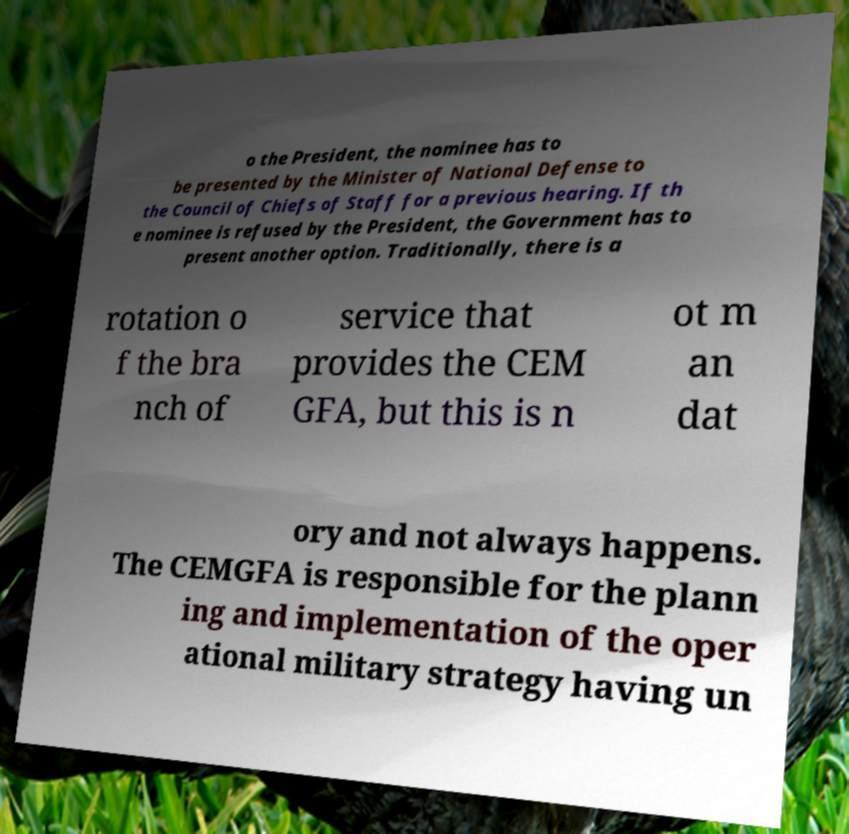Please read and relay the text visible in this image. What does it say? o the President, the nominee has to be presented by the Minister of National Defense to the Council of Chiefs of Staff for a previous hearing. If th e nominee is refused by the President, the Government has to present another option. Traditionally, there is a rotation o f the bra nch of service that provides the CEM GFA, but this is n ot m an dat ory and not always happens. The CEMGFA is responsible for the plann ing and implementation of the oper ational military strategy having un 